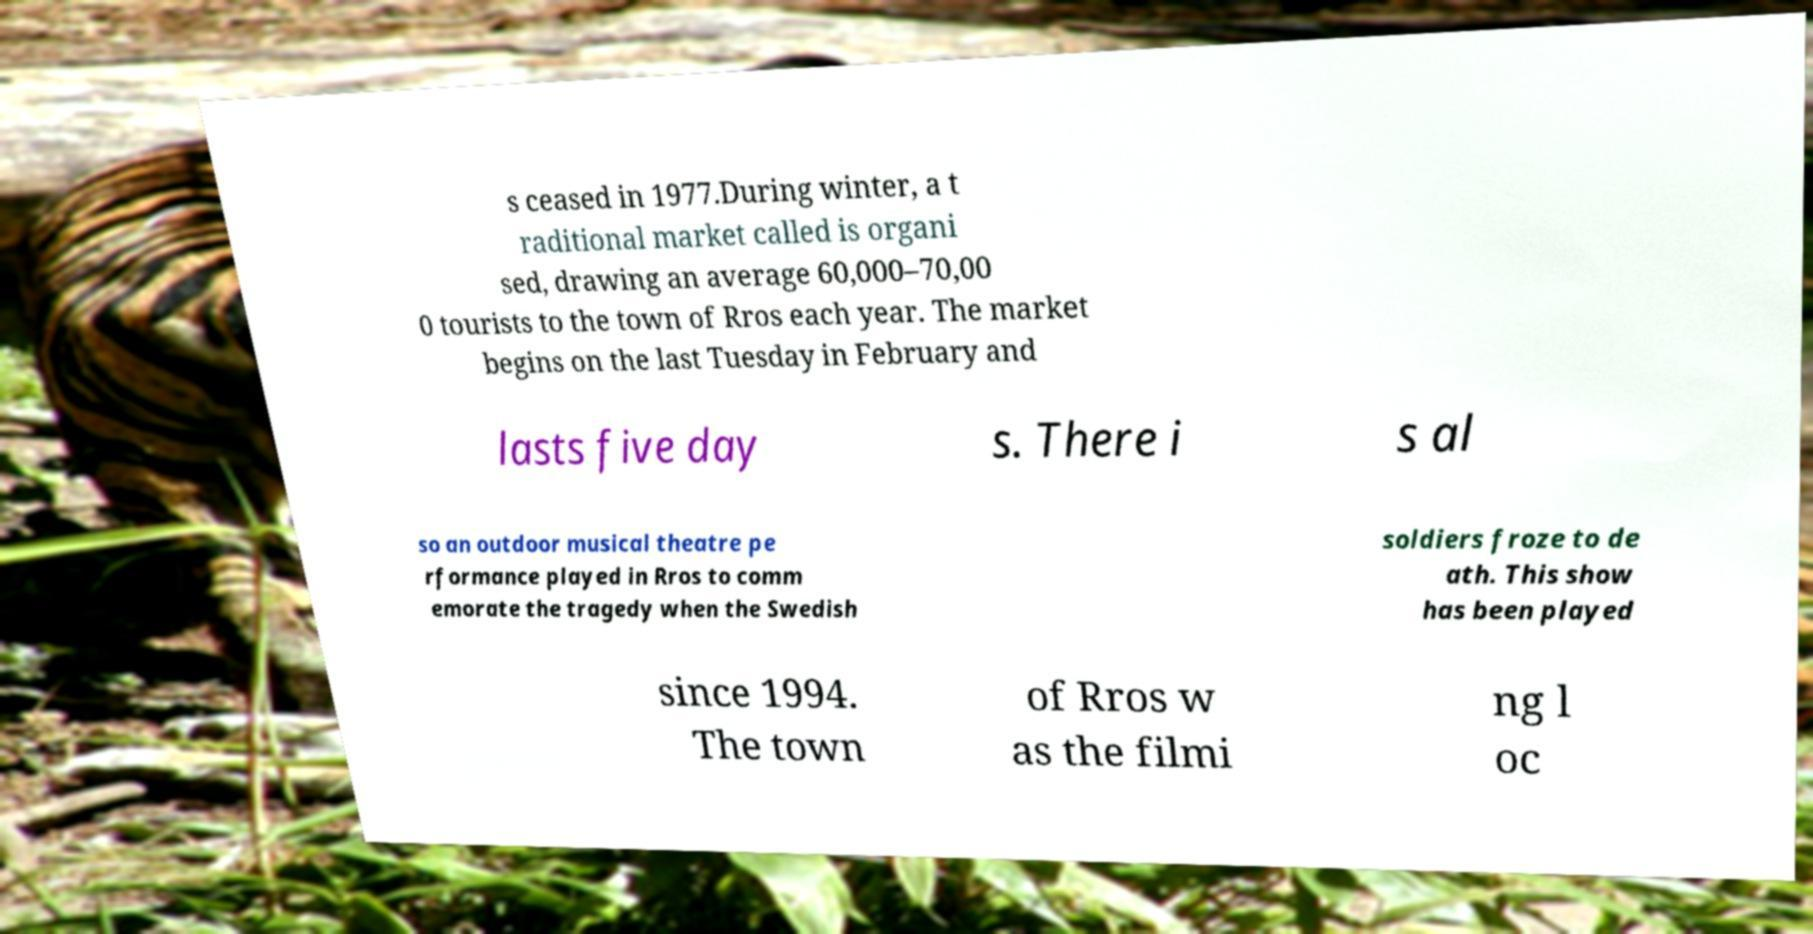What messages or text are displayed in this image? I need them in a readable, typed format. s ceased in 1977.During winter, a t raditional market called is organi sed, drawing an average 60,000–70,00 0 tourists to the town of Rros each year. The market begins on the last Tuesday in February and lasts five day s. There i s al so an outdoor musical theatre pe rformance played in Rros to comm emorate the tragedy when the Swedish soldiers froze to de ath. This show has been played since 1994. The town of Rros w as the filmi ng l oc 